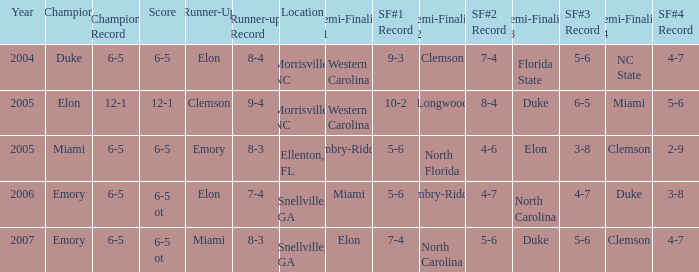How many teams were listed as runner up in 2005 and there the first semi finalist was Western Carolina? 1.0. 